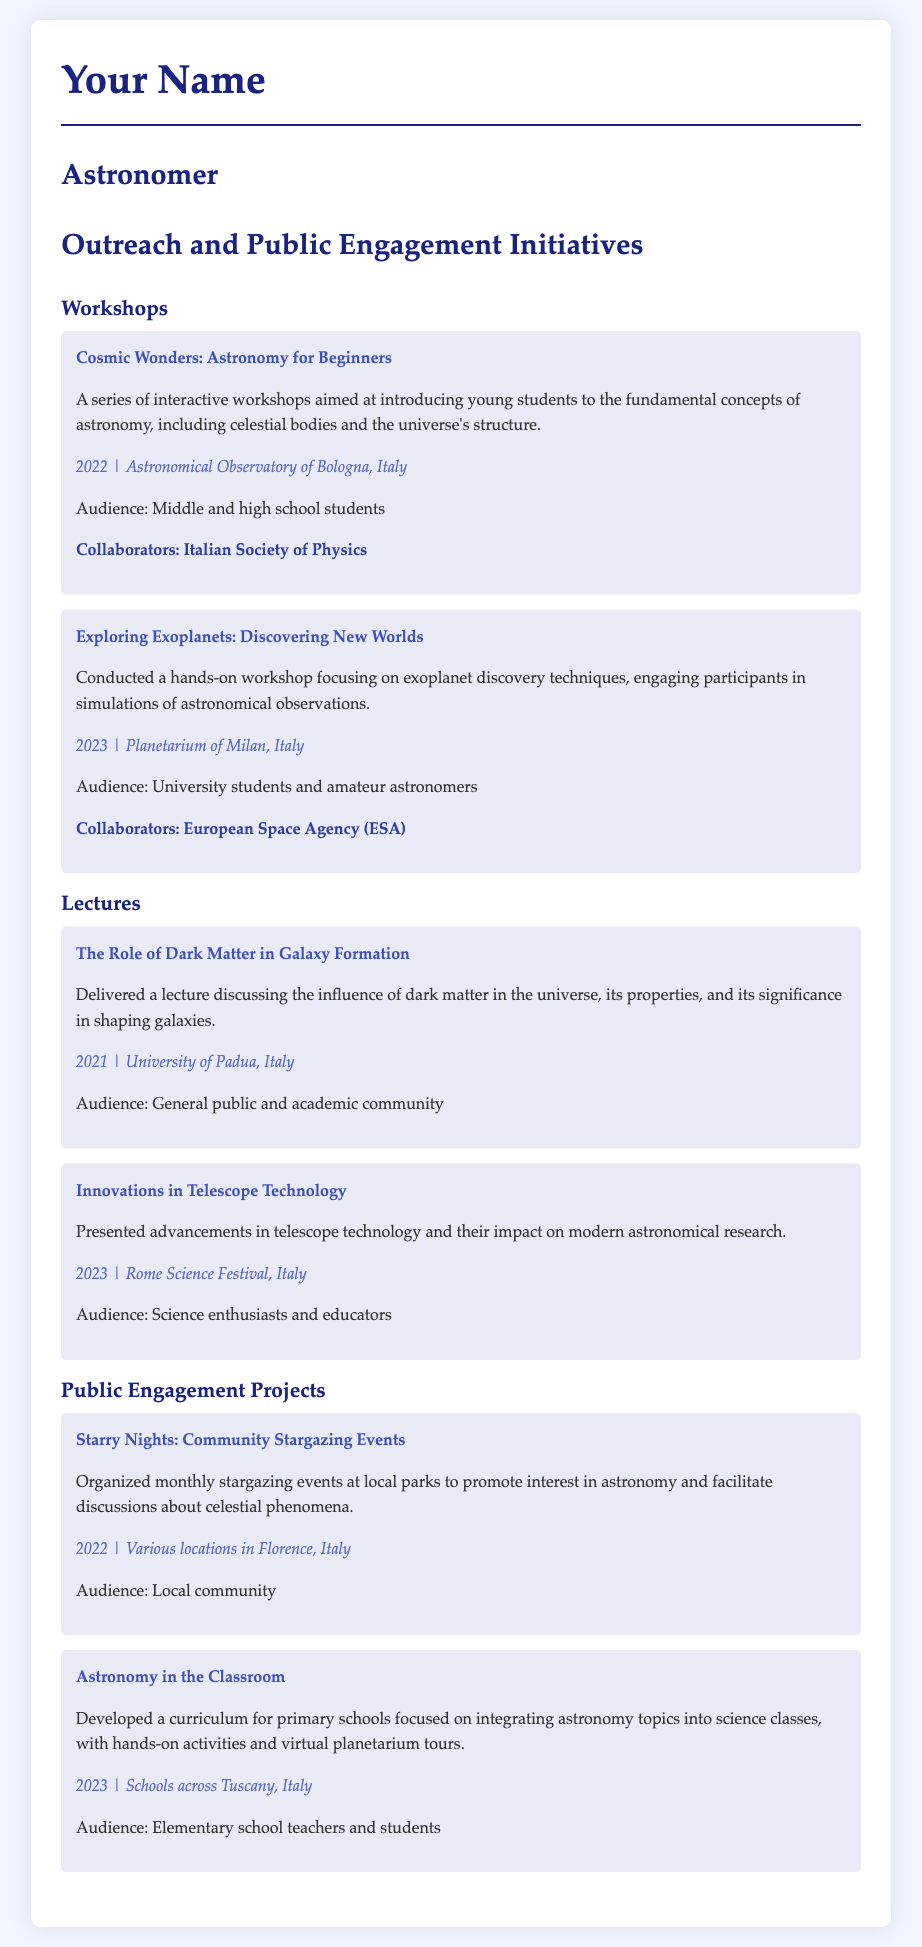what is the title of the first workshop listed? The title is the first line in the "Workshops" section, which refers to the specific interactive workshop.
Answer: Cosmic Wonders: Astronomy for Beginners who collaborated in the "Starry Nights: Community Stargazing Events"? This is mentioned as part of the initiative details, indicating who was involved in organizing the event.
Answer: Not specified in which year was the "Exploring Exoplanets: Discovering New Worlds" workshop conducted? The year is provided in the initiative details for the specific workshop mentioned.
Answer: 2023 what type of audience attended the lecture on "The Role of Dark Matter in Galaxy Formation"? The audience is described directly in the initiative details of the lecture, indicating the target group.
Answer: General public and academic community how many public engagement projects are mentioned in the document? This requires counting the distinct "Public Engagement Projects" listed in the section, which is provided in the CV.
Answer: 2 where was the workshop "Cosmic Wonders: Astronomy for Beginners" held? The location is clearly mentioned in the initiative details for the specific workshop.
Answer: Astronomical Observatory of Bologna, Italy which event included discussions about celestial phenomena? The event is identified in the document as facilitating discussions, clear from its description.
Answer: Starry Nights: Community Stargazing Events what is the focus of the project "Astronomy in the Classroom"? The focus is described in the project details, indicating the educational content and approach.
Answer: Integrating astronomy topics into science classes 